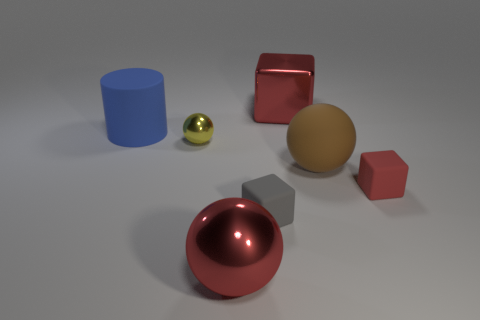Add 1 large shiny spheres. How many objects exist? 8 Subtract all rubber cubes. How many cubes are left? 1 Subtract all purple spheres. How many red cubes are left? 2 Subtract 1 cubes. How many cubes are left? 2 Subtract all cylinders. How many objects are left? 6 Subtract all purple cubes. Subtract all purple cylinders. How many cubes are left? 3 Add 2 spheres. How many spheres exist? 5 Subtract 0 green blocks. How many objects are left? 7 Subtract all tiny yellow metal cylinders. Subtract all large red shiny blocks. How many objects are left? 6 Add 4 small gray cubes. How many small gray cubes are left? 5 